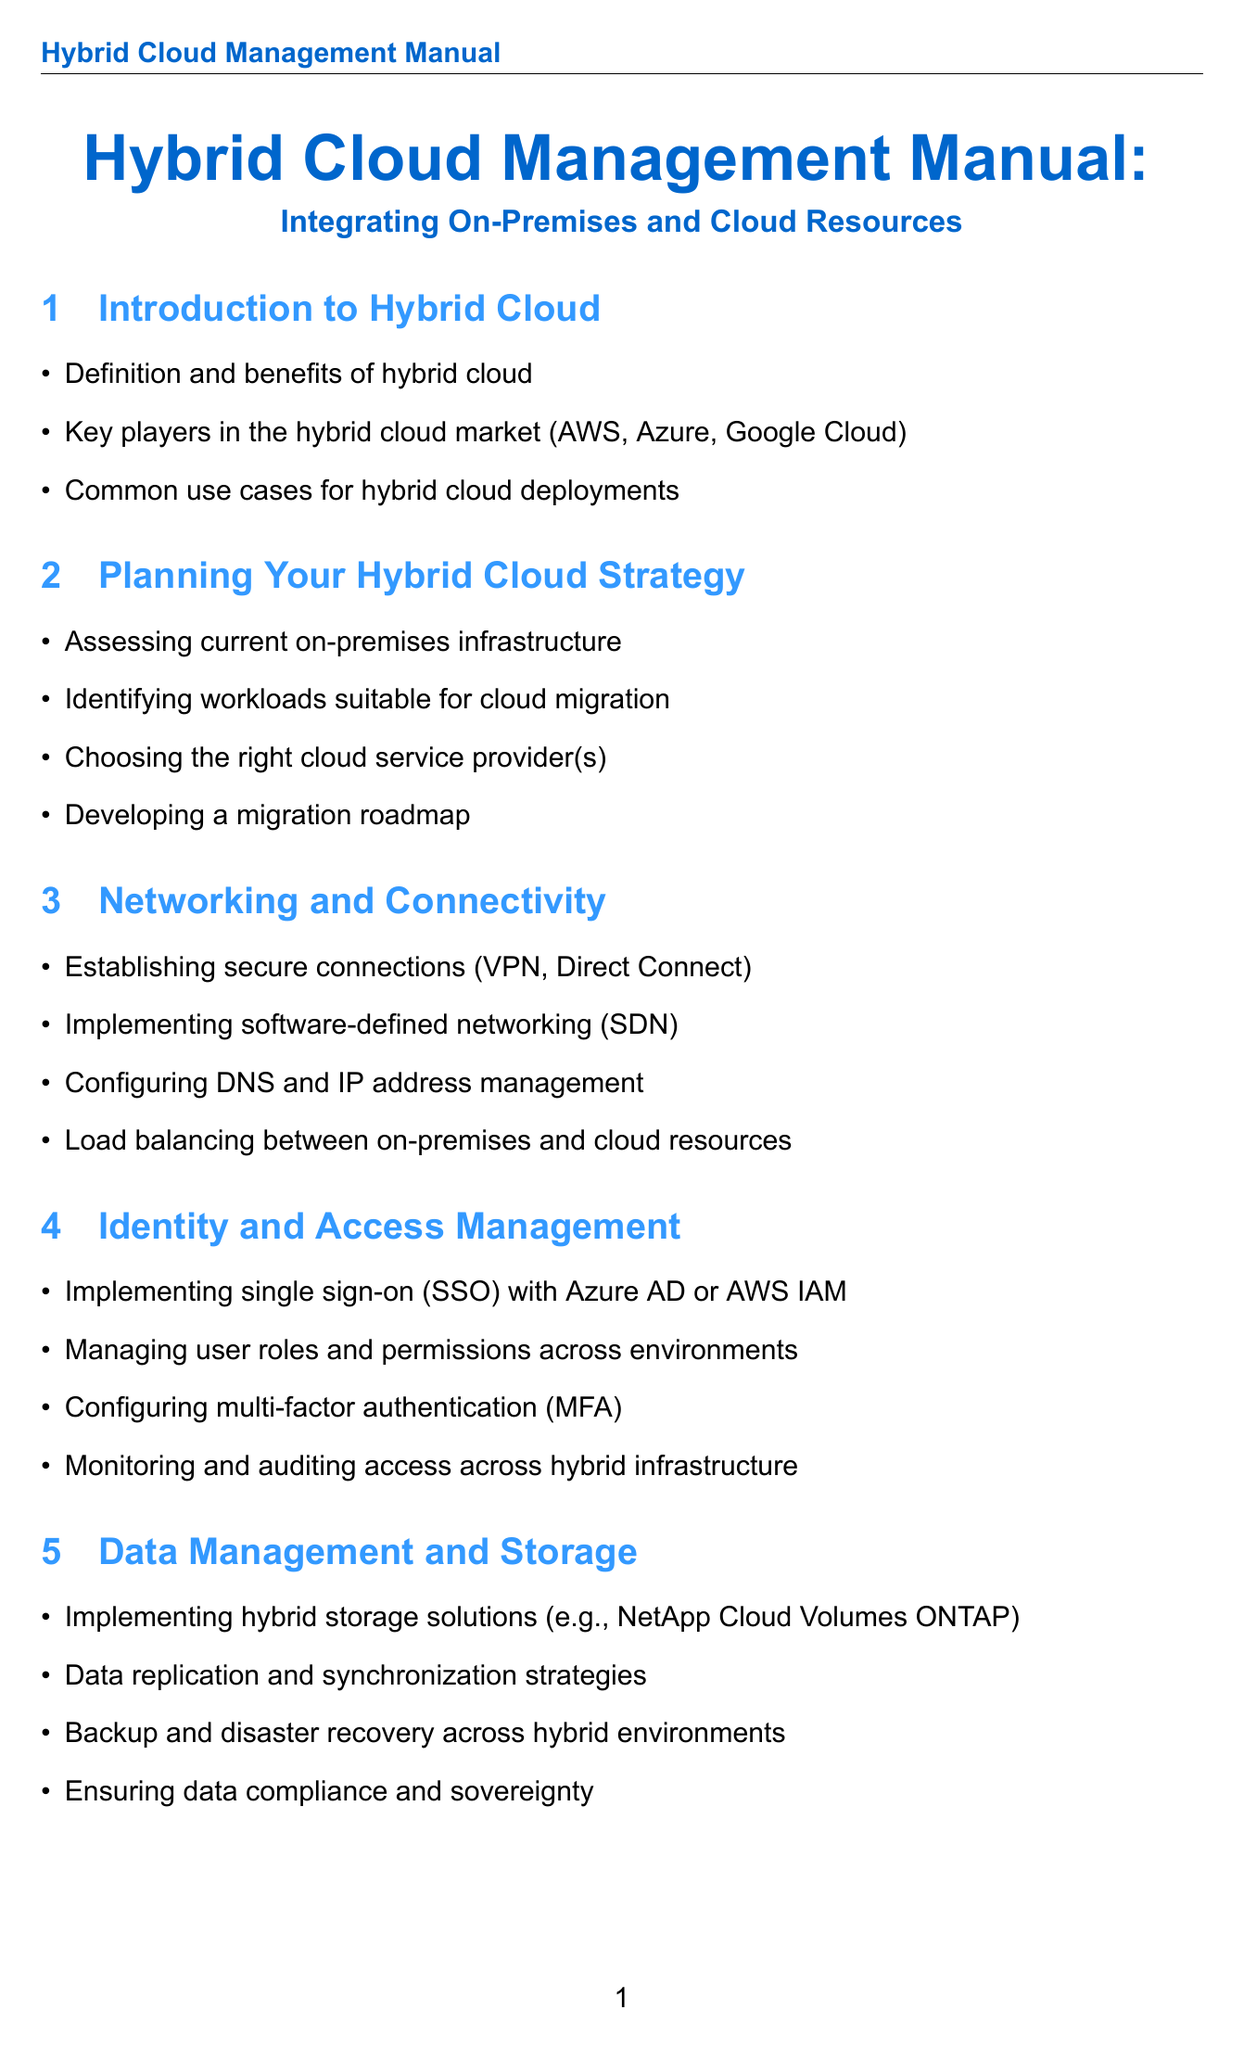What are the key players in the hybrid cloud market? The document lists AWS, Azure, and Google Cloud as the key players in the hybrid cloud market.
Answer: AWS, Azure, Google Cloud What is the main focus of the section "Networking and Connectivity"? This section discusses establishing secure connections, implementing software-defined networking, configuring DNS and IP address management, and load balancing.
Answer: Secure connections, SDN, DNS, Load balancing Which company is highlighted in the case study regarding hybrid cloud transformation? The document features JPMorgan Chase in the case study focused on hybrid cloud transformation.
Answer: JPMorgan Chase What technology is used for containerization in hybrid environments? The document mentions Docker and Kubernetes as technologies used for containerization.
Answer: Docker, Kubernetes What term is defined as an IT architecture integrating on-premises infrastructure with public cloud services? The glossary defines "Hybrid Cloud" in this context.
Answer: Hybrid Cloud What are the outcomes of Walmart's hybrid cloud journey? The document specifies seamless scaling during high-demand periods, improved inventory management, and enhanced customer experience across channels.
Answer: Seamless scaling, improved inventory management, enhanced customer experience What is a requirement for implementing single sign-on in hybrid cloud management? The document states that Azure AD or AWS IAM can be used for implementing single sign-on.
Answer: Azure AD or AWS IAM Which document section discusses data compliance and sovereignty? The section "Data Management and Storage" addresses data compliance and sovereignty.
Answer: Data Management and Storage 